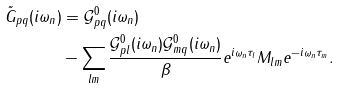Convert formula to latex. <formula><loc_0><loc_0><loc_500><loc_500>\tilde { G } _ { p q } ( i \omega _ { n } ) & = \mathcal { G } _ { p q } ^ { 0 } ( i \omega _ { n } ) \\ & - \sum _ { l m } \frac { \mathcal { G } _ { p l } ^ { 0 } ( i \omega _ { n } ) \mathcal { G } _ { m q } ^ { 0 } ( i \omega _ { n } ) } { \beta } e ^ { i \omega _ { n } \tau _ { l } } M _ { l m } e ^ { - i \omega _ { n } \tau _ { m } } .</formula> 